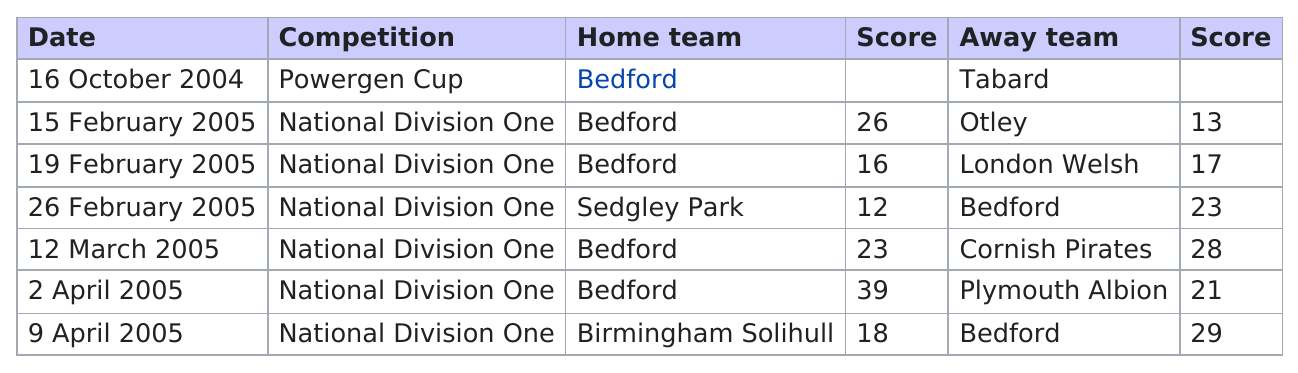Draw attention to some important aspects in this diagram. Bedford lost a total of two games this season. On February 19th, 2005, the home team had a score that was nearly the same as the away team. On October 16, 2004, there was no score recorded for a competition. Bedford scored 18 more points than Plymouth Albion in the 2 April 2005 game. In total, Bedford scored 156 points in all of their games. 